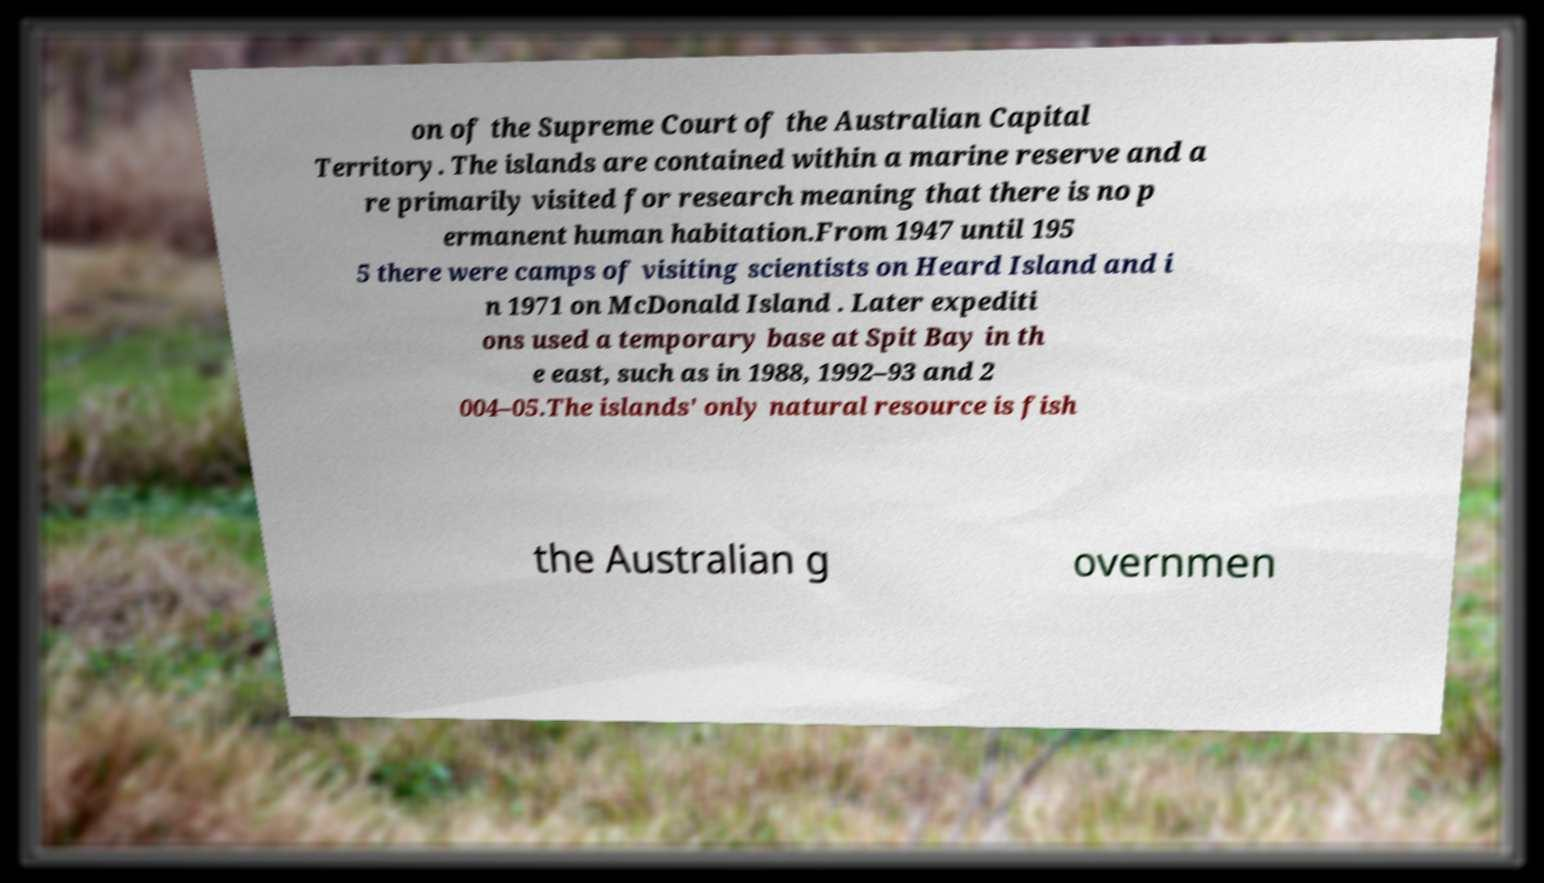Please read and relay the text visible in this image. What does it say? on of the Supreme Court of the Australian Capital Territory. The islands are contained within a marine reserve and a re primarily visited for research meaning that there is no p ermanent human habitation.From 1947 until 195 5 there were camps of visiting scientists on Heard Island and i n 1971 on McDonald Island . Later expediti ons used a temporary base at Spit Bay in th e east, such as in 1988, 1992–93 and 2 004–05.The islands' only natural resource is fish the Australian g overnmen 